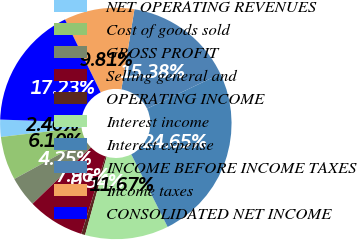Convert chart. <chart><loc_0><loc_0><loc_500><loc_500><pie_chart><fcel>NET OPERATING REVENUES<fcel>Cost of goods sold<fcel>GROSS PROFIT<fcel>Selling general and<fcel>OPERATING INCOME<fcel>Interest income<fcel>Interest expense<fcel>INCOME BEFORE INCOME TAXES<fcel>Income taxes<fcel>CONSOLIDATED NET INCOME<nl><fcel>2.4%<fcel>6.1%<fcel>4.25%<fcel>7.96%<fcel>0.54%<fcel>11.67%<fcel>24.65%<fcel>15.38%<fcel>9.81%<fcel>17.23%<nl></chart> 